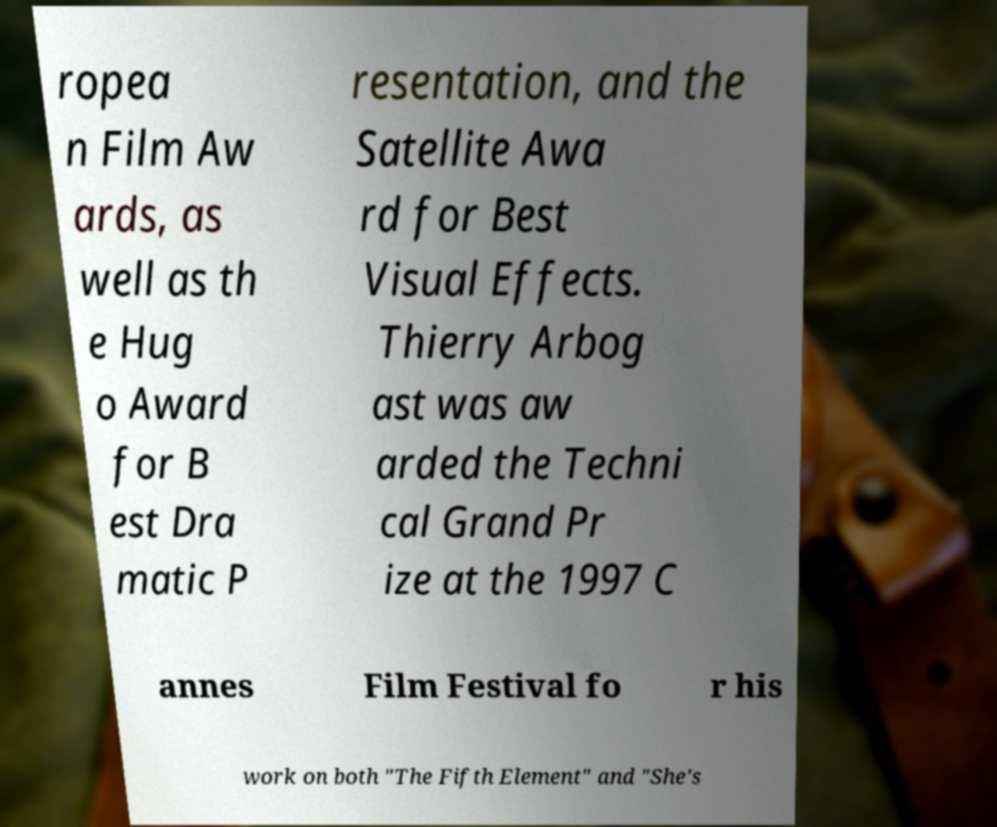Could you assist in decoding the text presented in this image and type it out clearly? ropea n Film Aw ards, as well as th e Hug o Award for B est Dra matic P resentation, and the Satellite Awa rd for Best Visual Effects. Thierry Arbog ast was aw arded the Techni cal Grand Pr ize at the 1997 C annes Film Festival fo r his work on both "The Fifth Element" and "She's 